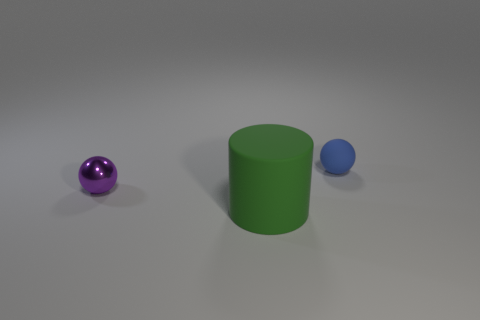Add 1 big green rubber cylinders. How many objects exist? 4 Subtract 0 red cylinders. How many objects are left? 3 Subtract all cylinders. How many objects are left? 2 Subtract all large red objects. Subtract all small blue matte balls. How many objects are left? 2 Add 1 small purple metallic objects. How many small purple metallic objects are left? 2 Add 1 large cyan cylinders. How many large cyan cylinders exist? 1 